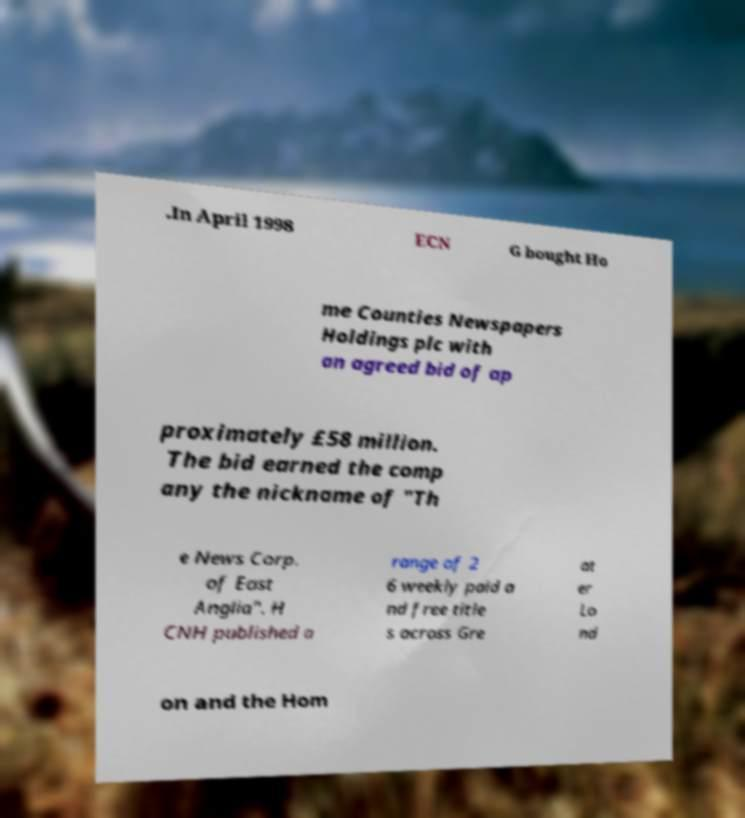What messages or text are displayed in this image? I need them in a readable, typed format. .In April 1998 ECN G bought Ho me Counties Newspapers Holdings plc with an agreed bid of ap proximately £58 million. The bid earned the comp any the nickname of "Th e News Corp. of East Anglia". H CNH published a range of 2 6 weekly paid a nd free title s across Gre at er Lo nd on and the Hom 